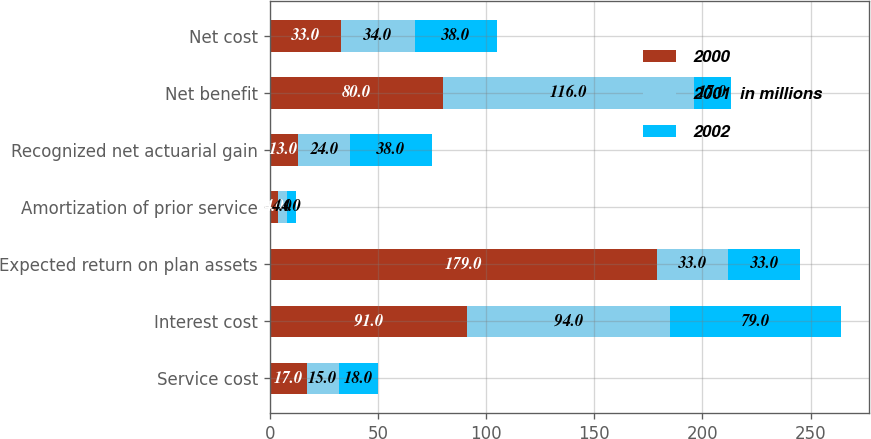<chart> <loc_0><loc_0><loc_500><loc_500><stacked_bar_chart><ecel><fcel>Service cost<fcel>Interest cost<fcel>Expected return on plan assets<fcel>Amortization of prior service<fcel>Recognized net actuarial gain<fcel>Net benefit<fcel>Net cost<nl><fcel>2000<fcel>17<fcel>91<fcel>179<fcel>4<fcel>13<fcel>80<fcel>33<nl><fcel>2001  in millions<fcel>15<fcel>94<fcel>33<fcel>4<fcel>24<fcel>116<fcel>34<nl><fcel>2002<fcel>18<fcel>79<fcel>33<fcel>4<fcel>38<fcel>17<fcel>38<nl></chart> 